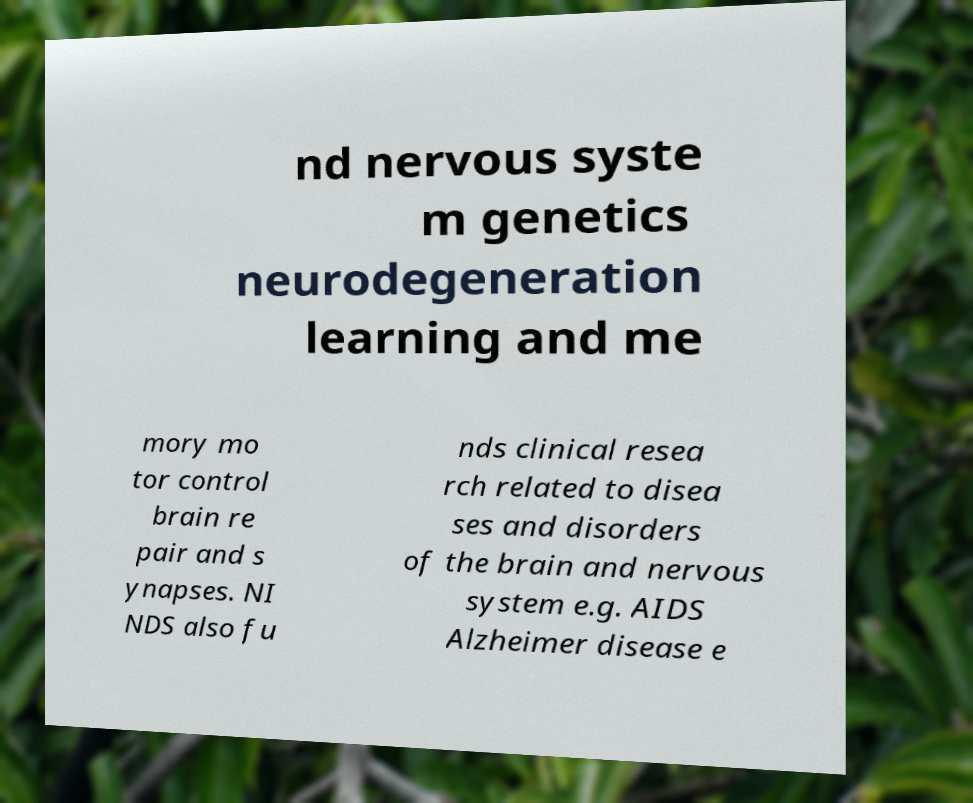Please read and relay the text visible in this image. What does it say? nd nervous syste m genetics neurodegeneration learning and me mory mo tor control brain re pair and s ynapses. NI NDS also fu nds clinical resea rch related to disea ses and disorders of the brain and nervous system e.g. AIDS Alzheimer disease e 